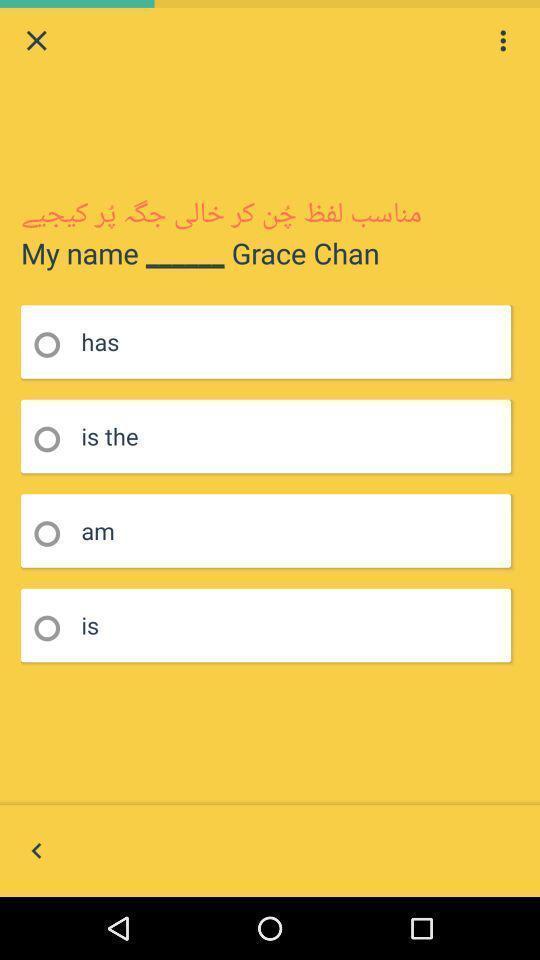Give me a narrative description of this picture. Page showing question with multiple options. 